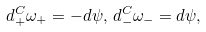<formula> <loc_0><loc_0><loc_500><loc_500>d ^ { C } _ { + } \omega _ { + } = - d \psi , \, d ^ { C } _ { - } \omega _ { - } = d \psi ,</formula> 